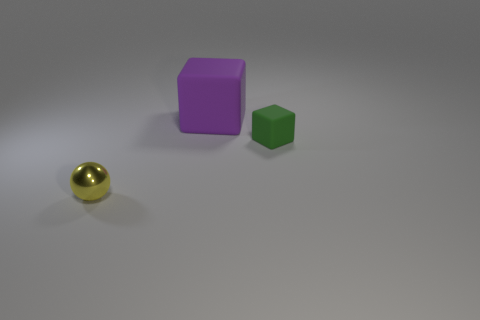Add 2 tiny green rubber cubes. How many objects exist? 5 Subtract all cubes. How many objects are left? 1 Add 2 purple matte cubes. How many purple matte cubes are left? 3 Add 1 big balls. How many big balls exist? 1 Subtract 0 purple cylinders. How many objects are left? 3 Subtract all big purple rubber objects. Subtract all matte blocks. How many objects are left? 0 